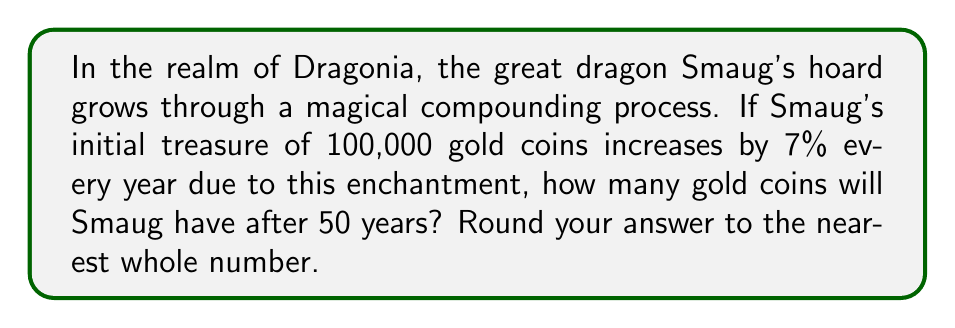Give your solution to this math problem. To solve this problem, we'll use the compound interest formula:

$$A = P(1 + r)^t$$

Where:
$A$ = Final amount
$P$ = Principal (initial investment)
$r$ = Annual interest rate (in decimal form)
$t$ = Time in years

Given:
$P = 100,000$ gold coins
$r = 7\% = 0.07$
$t = 50$ years

Let's plug these values into the formula:

$$A = 100,000(1 + 0.07)^{50}$$

Now, let's calculate step by step:

1) First, calculate $(1 + 0.07)$:
   $1 + 0.07 = 1.07$

2) Now, we need to raise 1.07 to the power of 50:
   $1.07^{50} \approx 29.4570$

3) Finally, multiply this by the initial amount:
   $100,000 \times 29.4570 \approx 2,945,703.52$

4) Rounding to the nearest whole number:
   $2,945,703.52 \approx 2,945,704$

Thus, after 50 years, Smaug's hoard will have grown to approximately 2,945,704 gold coins.
Answer: 2,945,704 gold coins 